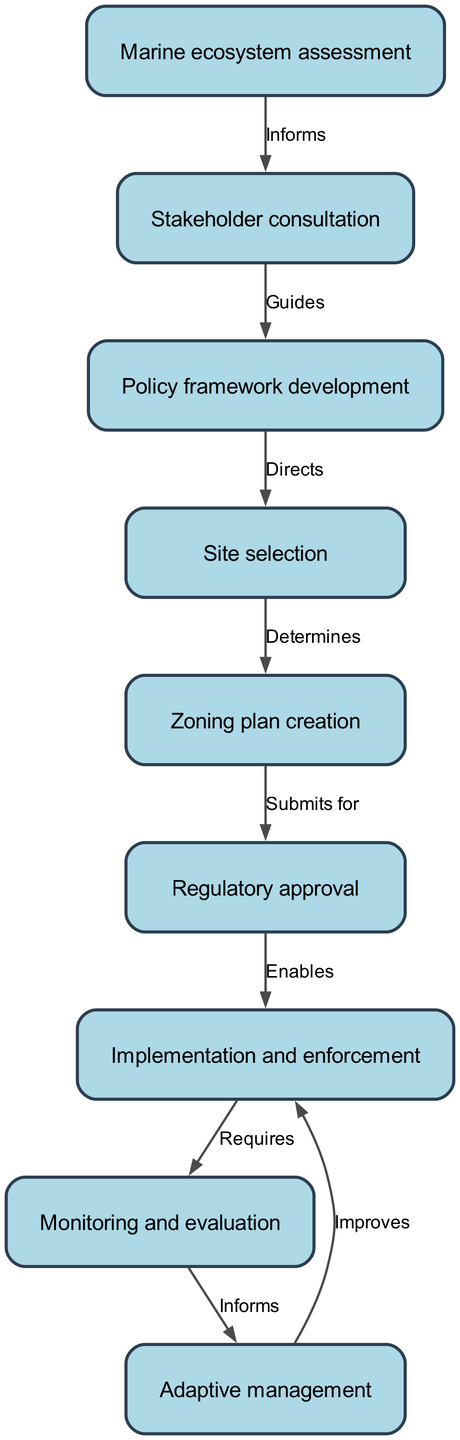What is the first step in the workflow? The diagram starts with the node "Marine ecosystem assessment," indicating this is the first step in establishing and managing marine protected areas.
Answer: Marine ecosystem assessment How many nodes are present in the diagram? By counting all the unique nodes listed, we find there are nine nodes: Marine ecosystem assessment, Stakeholder consultation, Policy framework development, Site selection, Zoning plan creation, Regulatory approval, Implementation and enforcement, Monitoring and evaluation, and Adaptive management.
Answer: 9 What relationship exists between Site selection and Zoning plan creation? The edge connecting these two nodes indicates that Site selection determines Zoning plan creation, which explains that the site chosen will influence how zoning plans are developed.
Answer: Determines Which node follows Regulatory approval? The diagram shows an edge leading from Regulatory approval to Implementation and enforcement, indicating that after regulatory approval, the next step is implementation and enforcement.
Answer: Implementation and enforcement What informs the Monitoring and evaluation step? The diagram specifies that Monitoring and evaluation is informed by the previous step, which is Implementation and enforcement, indicating that the outcomes from the implementation guide the monitoring process.
Answer: Implementation and enforcement How does Adaptive management connect back to previous steps? The edge from Adaptive management points back to Implementation and enforcement, suggesting that it improves this phase based on insights gained from Monitoring and evaluation, indicating a feedback loop.
Answer: Improves What guides the Policy framework development phase? The diagram shows that Stakeholder consultation guides Policy framework development, implying that input from stakeholders is critical in shaping the policy framework.
Answer: Guides How does Marine ecosystem assessment affect Stakeholder consultation? The edge indicates that Marine ecosystem assessment informs Stakeholder consultation, meaning that the assessment results provide necessary information that shapes discussions with stakeholders.
Answer: Informs Which step requires Monitoring and evaluation? The diagram clearly shows that Implementation and enforcement requires Monitoring and evaluation, highlighting the dependence of enforcement actions on ongoing monitoring efforts.
Answer: Requires 